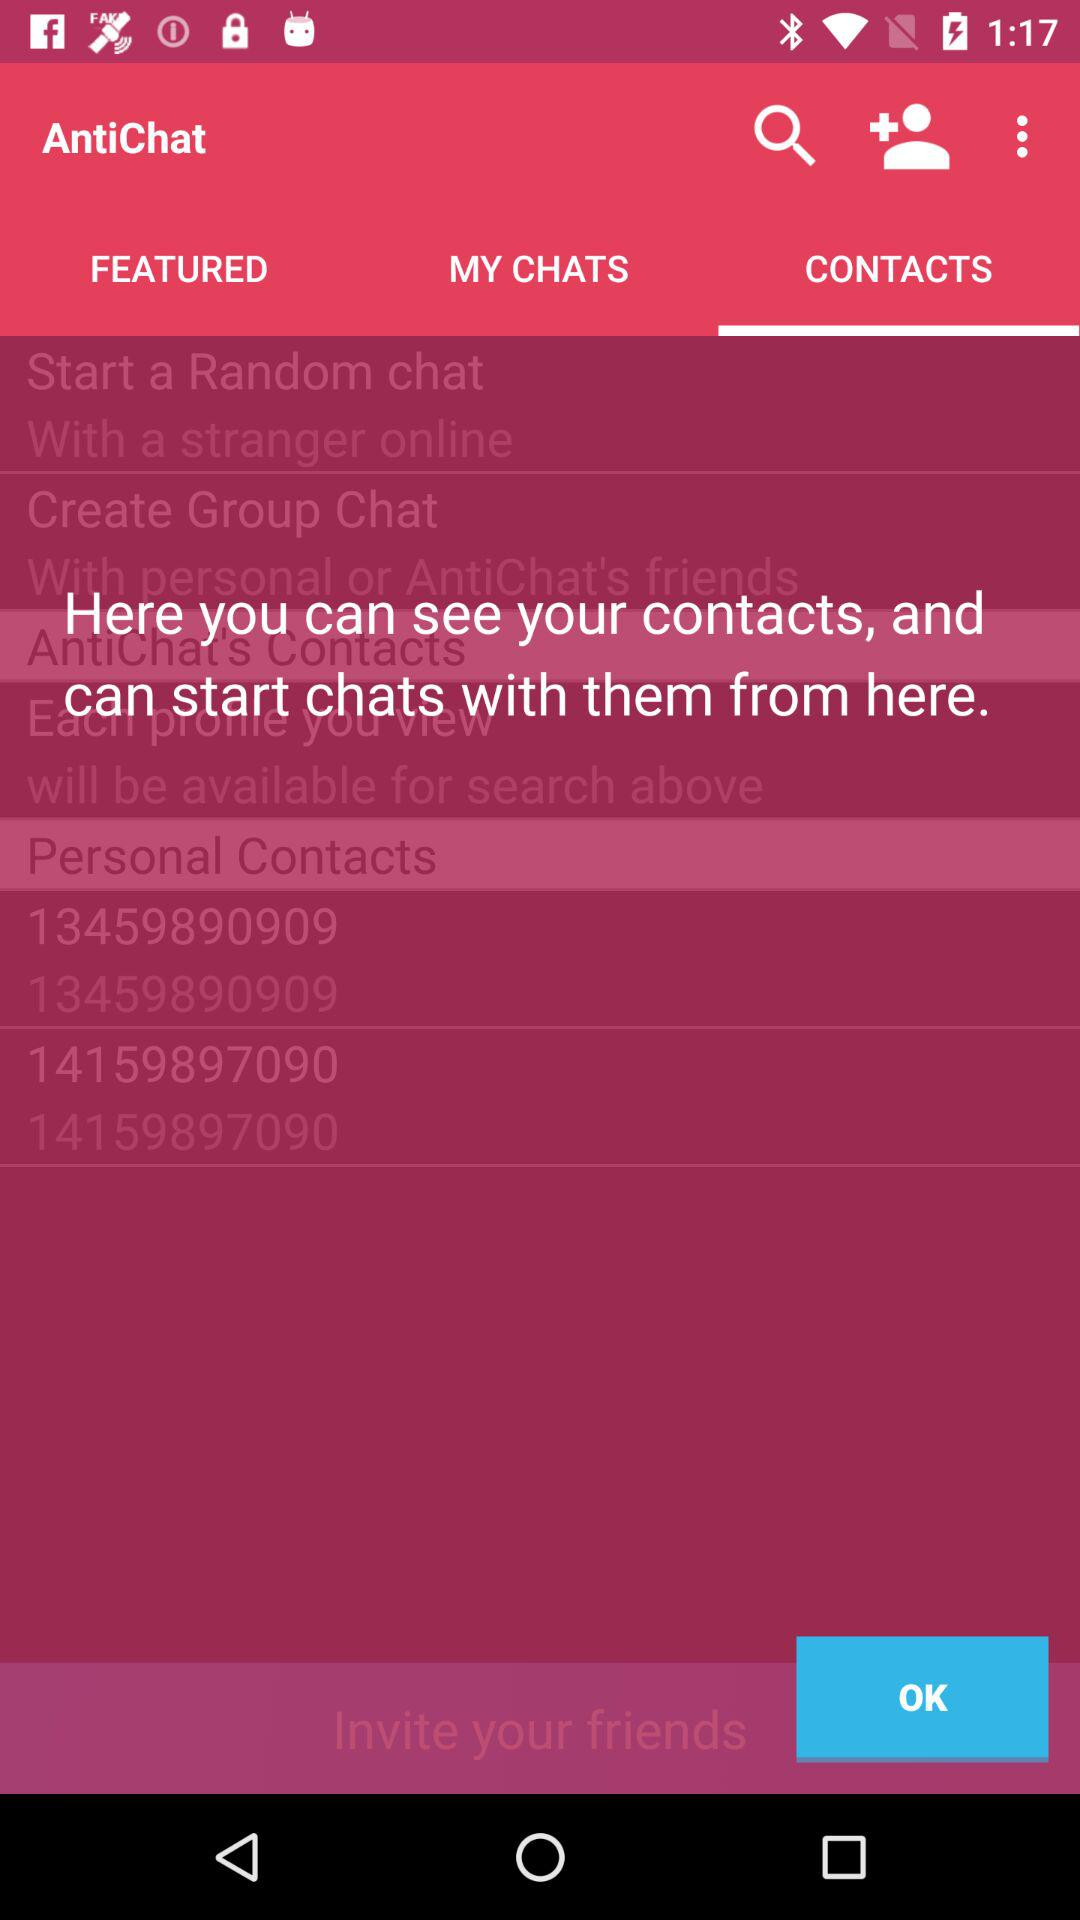What version of "AntiChat" is being used?
When the provided information is insufficient, respond with <no answer>. <no answer> 